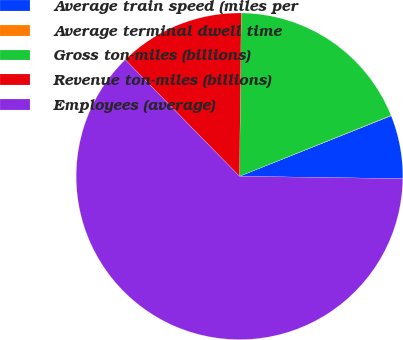Convert chart. <chart><loc_0><loc_0><loc_500><loc_500><pie_chart><fcel>Average train speed (miles per<fcel>Average terminal dwell time<fcel>Gross ton-miles (billions)<fcel>Revenue ton-miles (billions)<fcel>Employees (average)<nl><fcel>6.27%<fcel>0.04%<fcel>18.75%<fcel>12.51%<fcel>62.42%<nl></chart> 